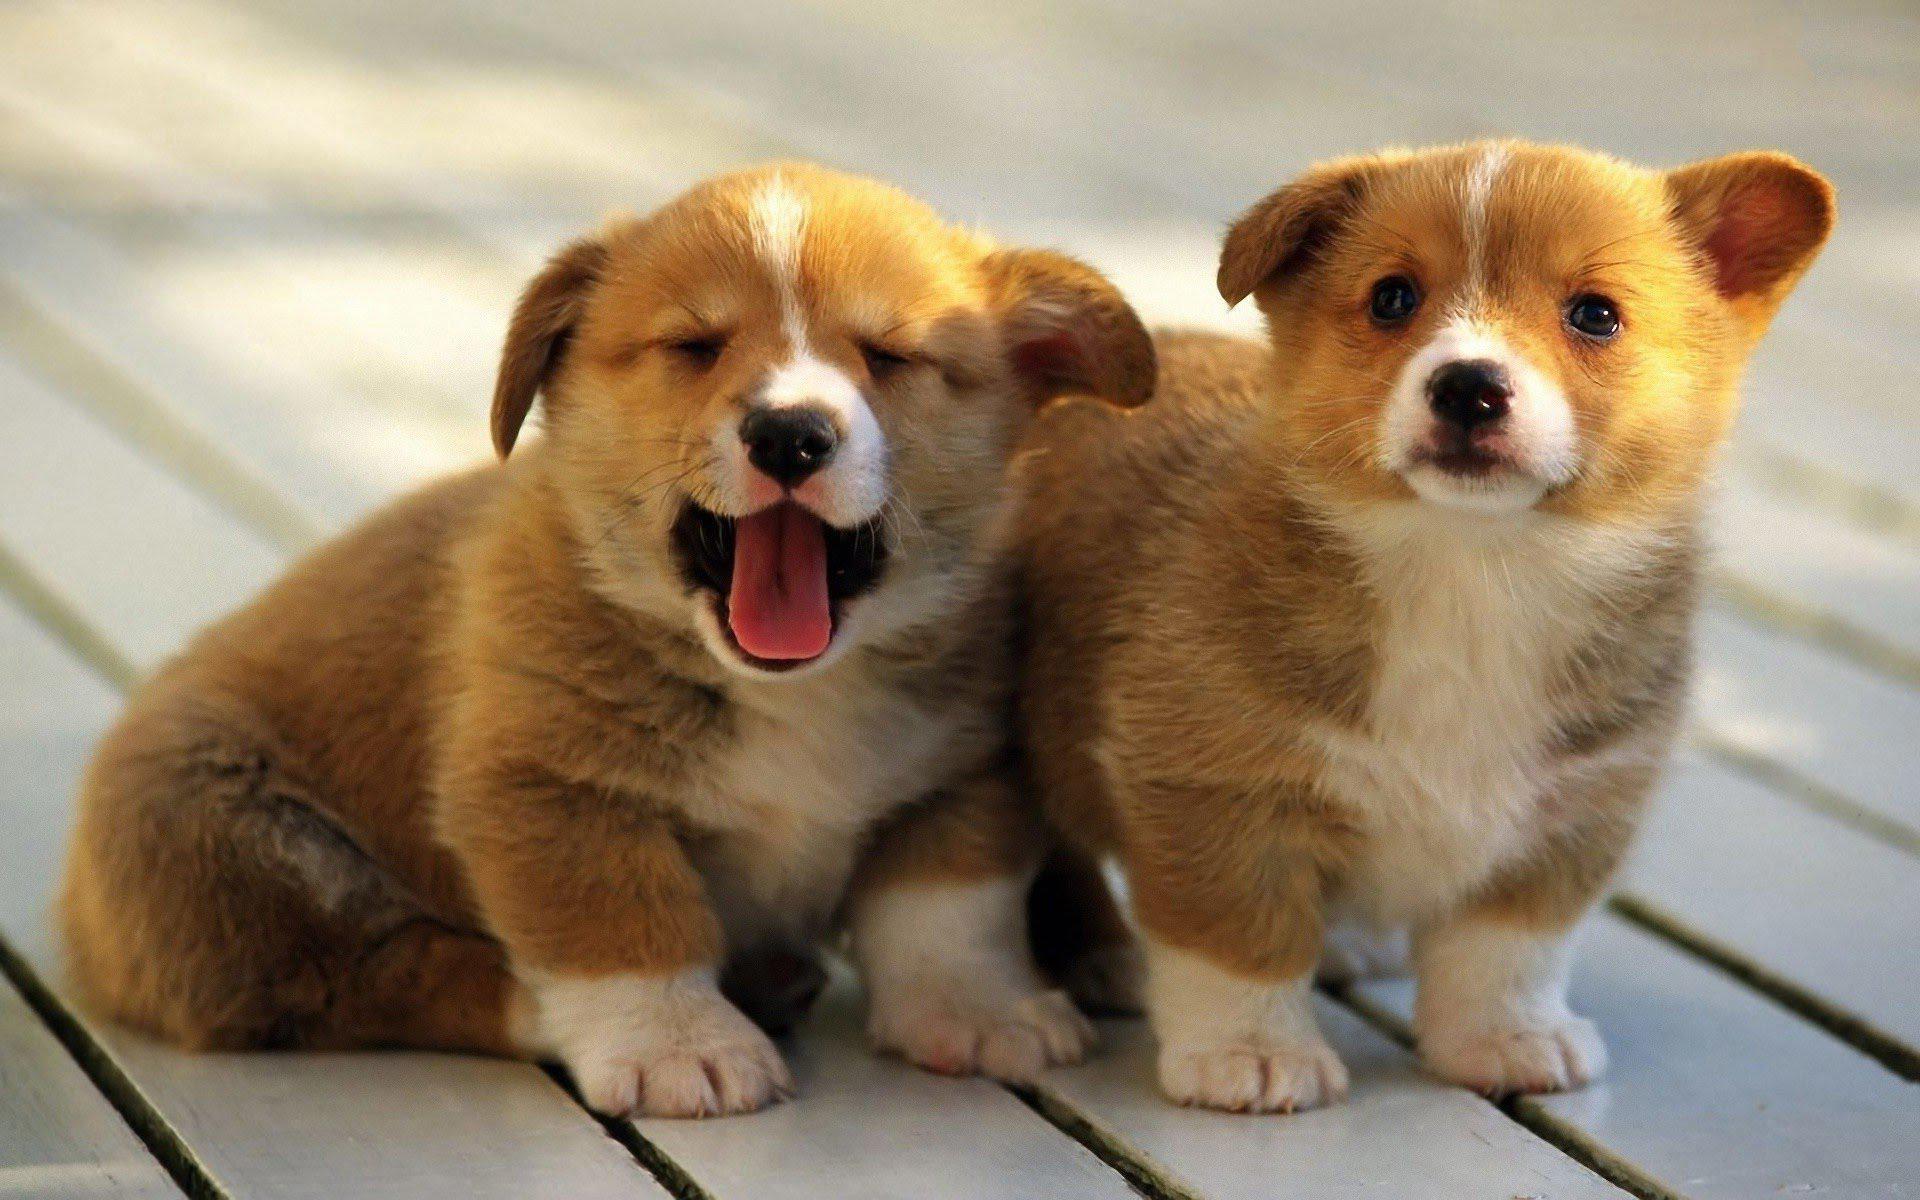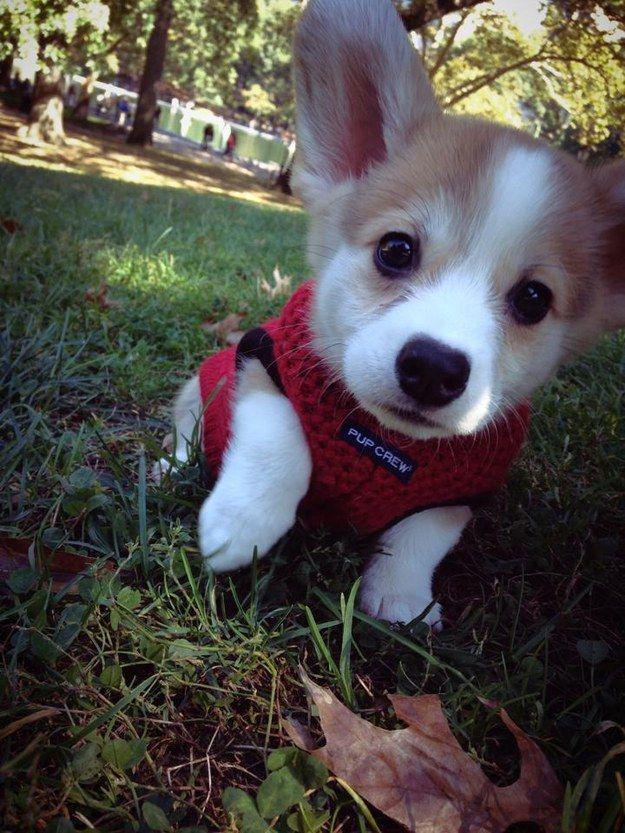The first image is the image on the left, the second image is the image on the right. For the images shown, is this caption "There are three dogs." true? Answer yes or no. Yes. The first image is the image on the left, the second image is the image on the right. Given the left and right images, does the statement "One image contains twice as many dogs as the other image and includes a dog standing on all fours facing forward." hold true? Answer yes or no. Yes. 